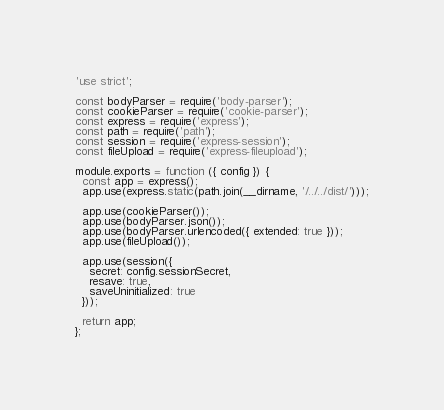Convert code to text. <code><loc_0><loc_0><loc_500><loc_500><_JavaScript_>'use strict';

const bodyParser = require('body-parser');
const cookieParser = require('cookie-parser');
const express = require('express');
const path = require('path');
const session = require('express-session');
const fileUpload = require('express-fileupload');

module.exports = function ({ config }) {
  const app = express();
  app.use(express.static(path.join(__dirname, '/../../dist/')));

  app.use(cookieParser());
  app.use(bodyParser.json());
  app.use(bodyParser.urlencoded({ extended: true }));
  app.use(fileUpload());

  app.use(session({
    secret: config.sessionSecret,
    resave: true,
    saveUninitialized: true
  }));

  return app;
};</code> 